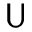<formula> <loc_0><loc_0><loc_500><loc_500>U</formula> 